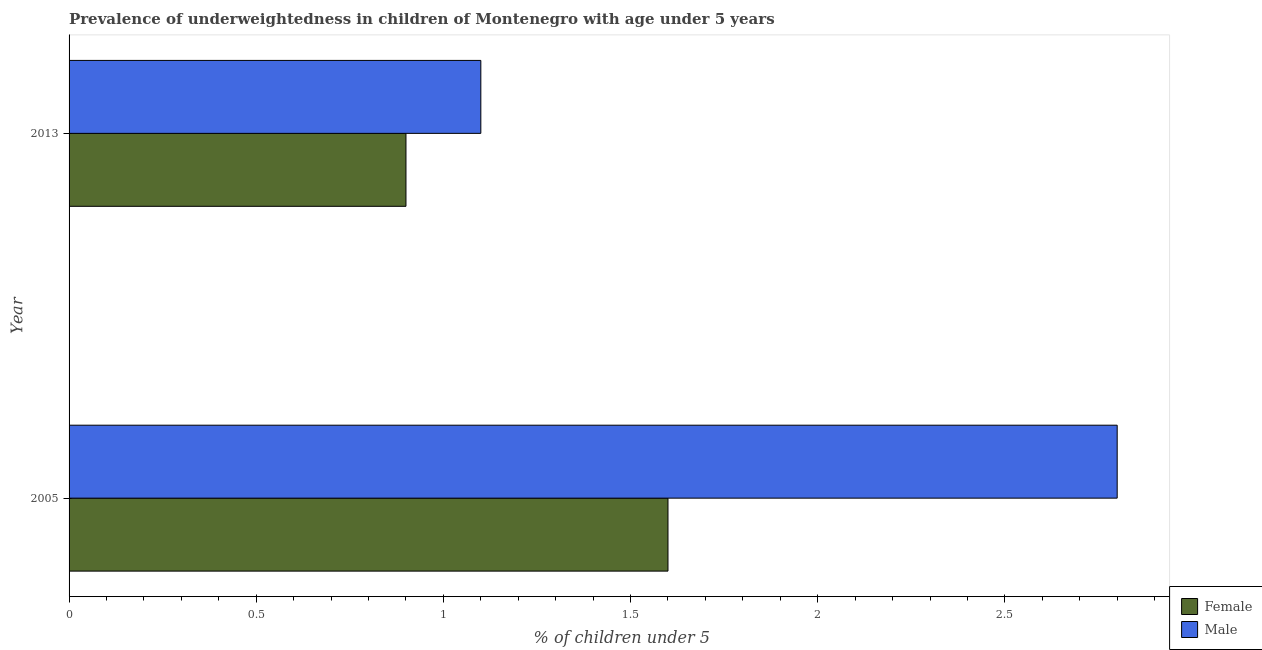How many groups of bars are there?
Keep it short and to the point. 2. Are the number of bars on each tick of the Y-axis equal?
Ensure brevity in your answer.  Yes. How many bars are there on the 1st tick from the top?
Your answer should be very brief. 2. How many bars are there on the 2nd tick from the bottom?
Offer a terse response. 2. What is the percentage of underweighted male children in 2005?
Provide a succinct answer. 2.8. Across all years, what is the maximum percentage of underweighted female children?
Provide a short and direct response. 1.6. Across all years, what is the minimum percentage of underweighted male children?
Give a very brief answer. 1.1. In which year was the percentage of underweighted female children maximum?
Give a very brief answer. 2005. What is the total percentage of underweighted male children in the graph?
Ensure brevity in your answer.  3.9. What is the difference between the percentage of underweighted female children in 2005 and that in 2013?
Ensure brevity in your answer.  0.7. What is the difference between the percentage of underweighted male children in 2005 and the percentage of underweighted female children in 2013?
Keep it short and to the point. 1.9. What is the average percentage of underweighted male children per year?
Your answer should be compact. 1.95. In how many years, is the percentage of underweighted female children greater than 0.30000000000000004 %?
Your answer should be compact. 2. What is the ratio of the percentage of underweighted female children in 2005 to that in 2013?
Offer a terse response. 1.78. Is the percentage of underweighted male children in 2005 less than that in 2013?
Provide a short and direct response. No. In how many years, is the percentage of underweighted male children greater than the average percentage of underweighted male children taken over all years?
Make the answer very short. 1. Are the values on the major ticks of X-axis written in scientific E-notation?
Provide a succinct answer. No. Does the graph contain grids?
Your answer should be compact. No. Where does the legend appear in the graph?
Offer a terse response. Bottom right. How many legend labels are there?
Ensure brevity in your answer.  2. What is the title of the graph?
Offer a terse response. Prevalence of underweightedness in children of Montenegro with age under 5 years. What is the label or title of the X-axis?
Ensure brevity in your answer.   % of children under 5. What is the label or title of the Y-axis?
Ensure brevity in your answer.  Year. What is the  % of children under 5 in Female in 2005?
Offer a very short reply. 1.6. What is the  % of children under 5 in Male in 2005?
Ensure brevity in your answer.  2.8. What is the  % of children under 5 of Female in 2013?
Your answer should be very brief. 0.9. What is the  % of children under 5 of Male in 2013?
Make the answer very short. 1.1. Across all years, what is the maximum  % of children under 5 of Female?
Offer a very short reply. 1.6. Across all years, what is the maximum  % of children under 5 of Male?
Provide a short and direct response. 2.8. Across all years, what is the minimum  % of children under 5 of Female?
Your answer should be very brief. 0.9. Across all years, what is the minimum  % of children under 5 in Male?
Your answer should be very brief. 1.1. What is the difference between the  % of children under 5 in Male in 2005 and that in 2013?
Offer a terse response. 1.7. What is the average  % of children under 5 in Female per year?
Provide a succinct answer. 1.25. What is the average  % of children under 5 of Male per year?
Offer a very short reply. 1.95. In the year 2005, what is the difference between the  % of children under 5 of Female and  % of children under 5 of Male?
Your answer should be very brief. -1.2. In the year 2013, what is the difference between the  % of children under 5 of Female and  % of children under 5 of Male?
Your answer should be very brief. -0.2. What is the ratio of the  % of children under 5 in Female in 2005 to that in 2013?
Make the answer very short. 1.78. What is the ratio of the  % of children under 5 of Male in 2005 to that in 2013?
Your response must be concise. 2.55. What is the difference between the highest and the lowest  % of children under 5 in Female?
Offer a terse response. 0.7. What is the difference between the highest and the lowest  % of children under 5 in Male?
Provide a short and direct response. 1.7. 